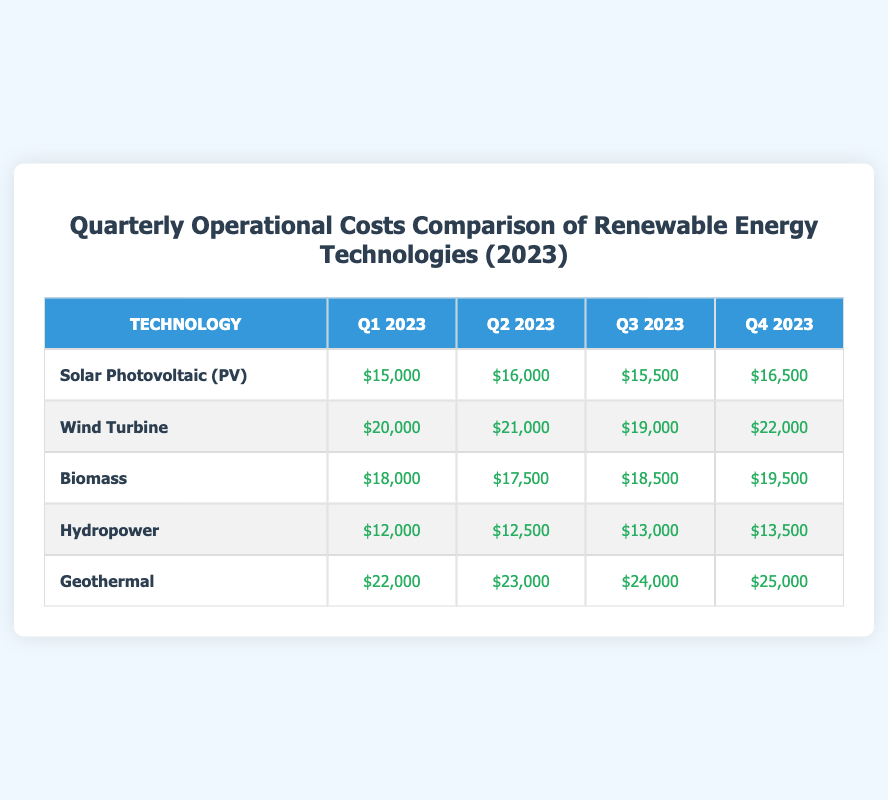What were the operational costs for Hydropower in Q2 2023? The table shows that the operational cost for Hydropower in Q2 2023 is $12,500.
Answer: $12,500 Which renewable energy technology had the highest operational cost in Q4 2023? By reviewing the data for Q4 2023, Geothermal has the highest operational cost at $25,000 compared to the other technologies listed.
Answer: Geothermal What is the total operational cost for Biomass across all four quarters? To calculate the total for Biomass, we add the costs: $18,000 + $17,500 + $18,500 + $19,500 = $73,500.
Answer: $73,500 Did Wind Turbine have a lower operational cost in Q3 2023 than in Q1 2023? The Q3 2023 cost for Wind Turbine is $19,000, which is lower than the Q1 2023 cost of $20,000, therefore the statement is true.
Answer: Yes What is the average operational cost for Solar Photovoltaic (PV) over the four quarters? The costs for Solar PV are $15,000, $16,000, $15,500, and $16,500. The total is $63,000, and there are four quarters, so the average cost is $63,000 / 4 = $15,750.
Answer: $15,750 Which technology had the largest increase in operational costs from Q1 to Q2 2023? For Q1 to Q2 2023, Solar PV increased from $15,000 to $16,000 (an increase of $1,000), Wind Turbine from $20,000 to $21,000 ($1,000), Biomass from $18,000 to $17,500 (decrease), Hydropower from $12,000 to $12,500 ($500), and Geothermal from $22,000 to $23,000 ($1,000). None had a larger increase than $1,000, so there's a tie among these three.
Answer: Solar PV, Wind Turbine, and Geothermal had a tie of $1,000 increase What is the difference in operational costs between Geothermal and Hydropower in Q3 2023? For Q3 2023, Geothermal's cost is $24,000 and Hydropower's is $13,000. The difference is $24,000 - $13,000 = $11,000.
Answer: $11,000 Is it true that the operational cost for Wind Turbine decreased from Q2 to Q3 in 2023? Yes, in Q2 2023 the cost was $21,000 and it decreased to $19,000 in Q3 2023. Thus, the statement is true.
Answer: Yes 